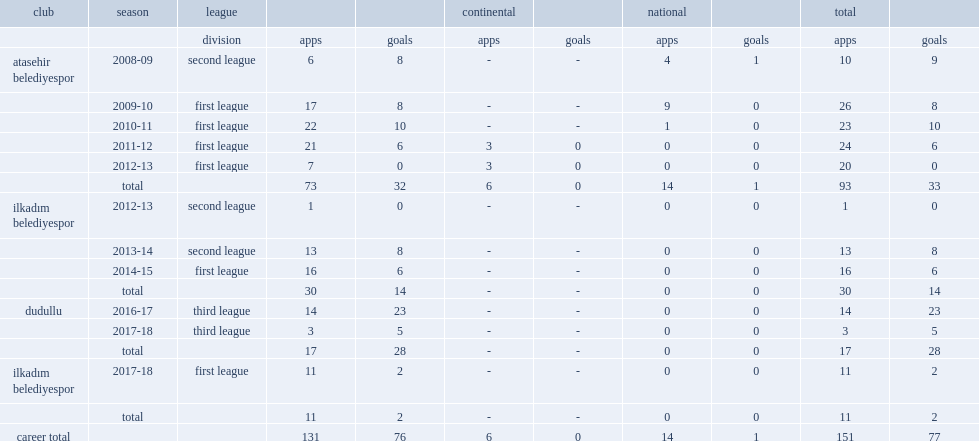Which club did fatma serdar return with in the third league, in 2016-17 season? Dudullu. 